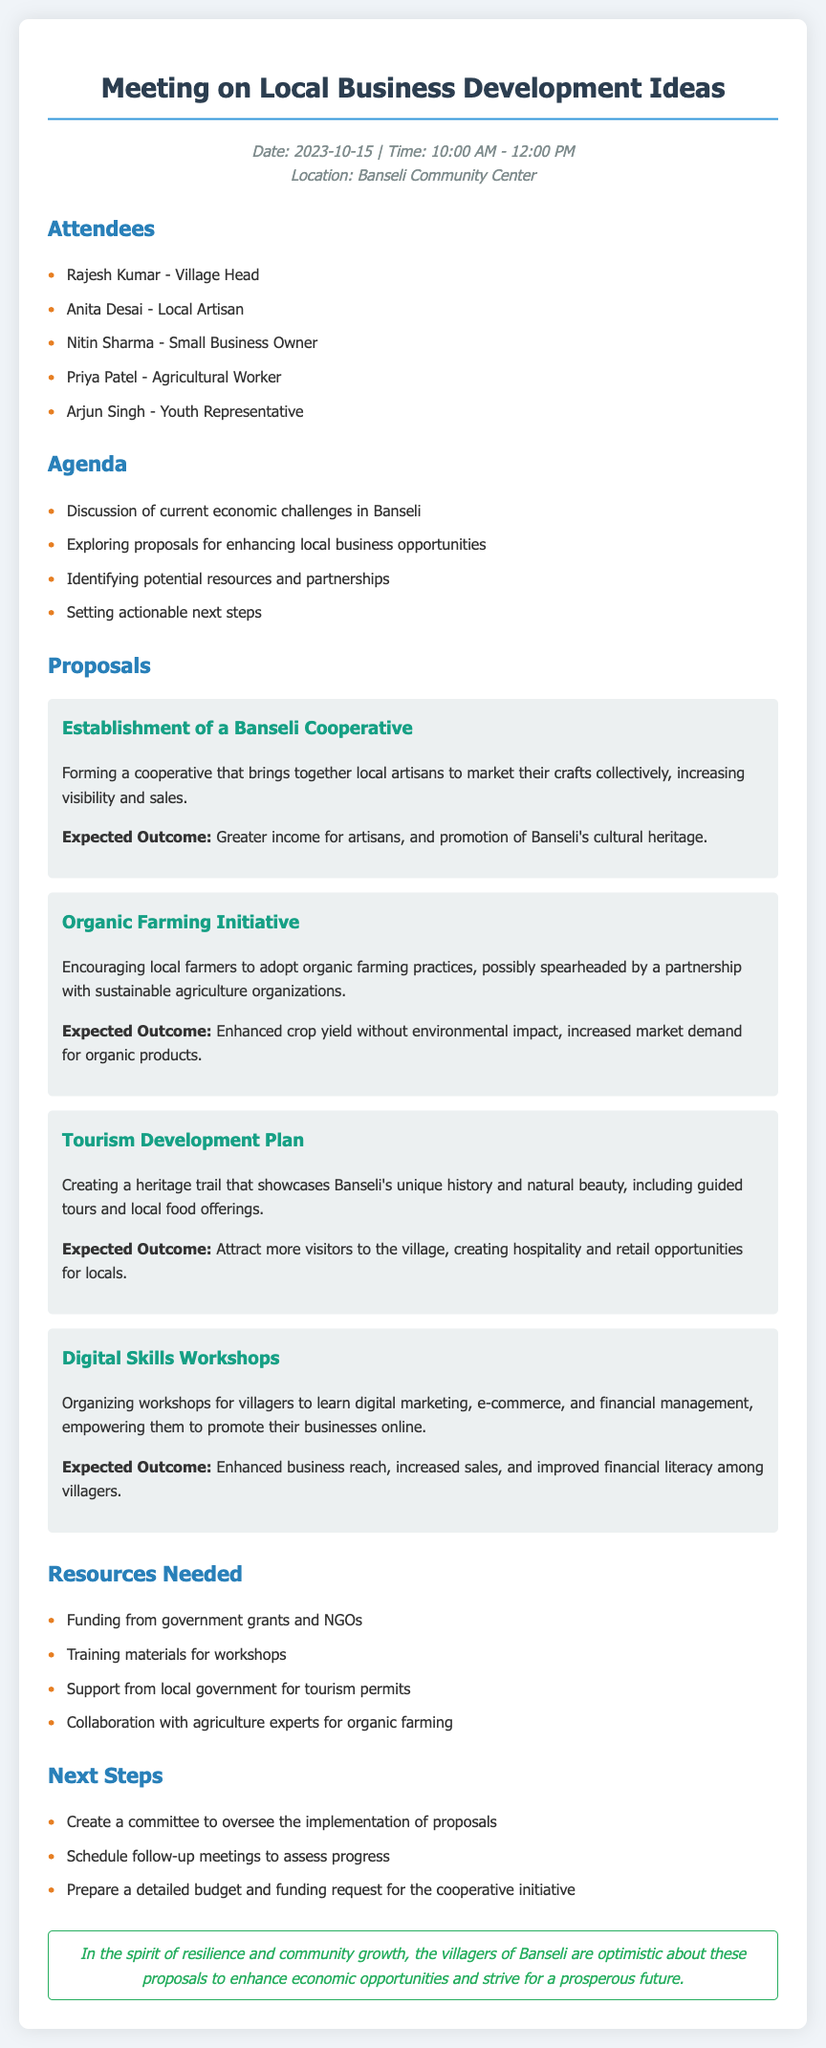What date was the meeting held? The meeting was held on October 15, 2023, as mentioned in the meta-info section.
Answer: October 15, 2023 Who proposed the Organic Farming Initiative? The document lists proposals but does not specify who proposed each initiative.
Answer: Not specified What is one expected outcome of the Establishment of a Banseli Cooperative? An expected outcome listed is greater income for artisans and promotion of Banseli's cultural heritage.
Answer: Greater income for artisans How long did the meeting last? The meeting started at 10:00 AM and ended at 12:00 PM, lasting for 2 hours.
Answer: 2 hours What resource is needed for the Digital Skills Workshops? The document states that training materials for workshops are needed.
Answer: Training materials How many proposals are listed in the document? The proposals section contains four distinct proposals.
Answer: Four Who is the village head attending the meeting? Rajesh Kumar is mentioned as the village head in the attendees list.
Answer: Rajesh Kumar What is the purpose of creating a committee? The committee is to oversee the implementation of proposals, as stated in the next steps section.
Answer: To oversee implementation What is the last statement in the document about? The closing statement focuses on resilience and optimism for community growth and economic opportunities.
Answer: Resilience and community growth 